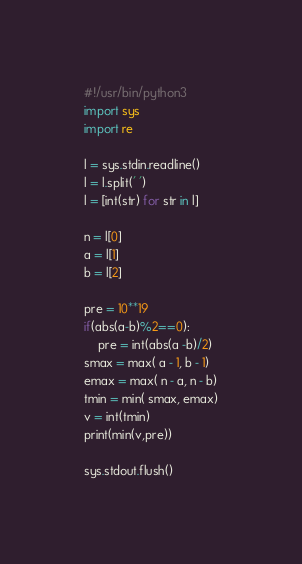Convert code to text. <code><loc_0><loc_0><loc_500><loc_500><_Python_>#!/usr/bin/python3
import sys
import re

l = sys.stdin.readline()
l = l.split(' ')
l = [int(str) for str in l]

n = l[0]
a = l[1]
b = l[2]

pre = 10**19
if(abs(a-b)%2==0):
	pre = int(abs(a -b)/2)
smax = max( a - 1, b - 1)
emax = max( n - a, n - b)
tmin = min( smax, emax)
v = int(tmin)
print(min(v,pre))

sys.stdout.flush()
</code> 